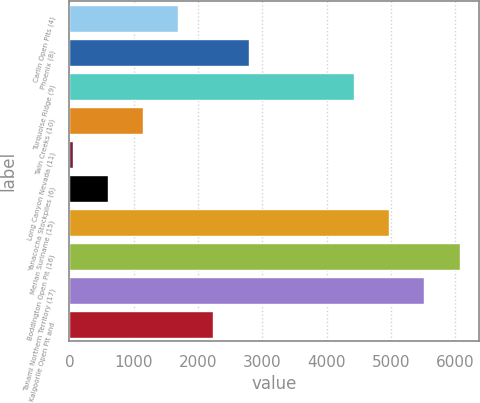Convert chart. <chart><loc_0><loc_0><loc_500><loc_500><bar_chart><fcel>Carlin Open Pits (4)<fcel>Phoenix (8)<fcel>Turquoise Ridge (9)<fcel>Twin Creeks (10)<fcel>Long Canyon Nevada (11)<fcel>Yanacocha Stockpiles (6)<fcel>Merian Suriname (15)<fcel>Boddington Open Pit (16)<fcel>Tanami Northern Territory (17)<fcel>Kalgoorlie Open Pit and<nl><fcel>1691<fcel>2785<fcel>4426<fcel>1144<fcel>50<fcel>597<fcel>4973<fcel>6067<fcel>5520<fcel>2238<nl></chart> 